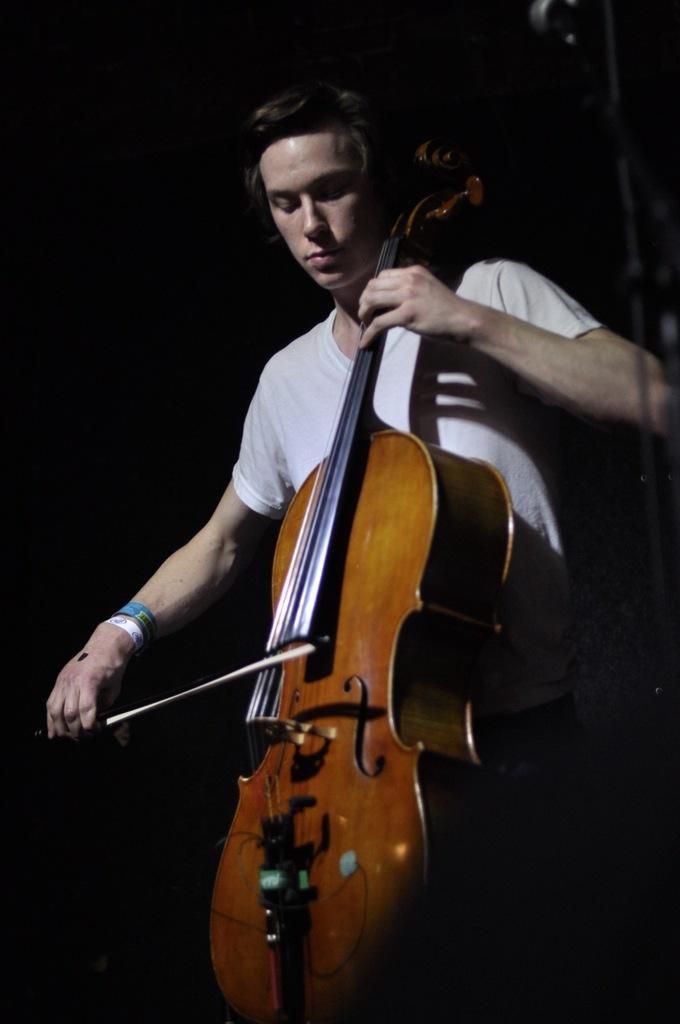Can you describe this image briefly? In this image, we can see a person who is wearing a white color T-shirt is playing a musical instrument. The background is dark. 